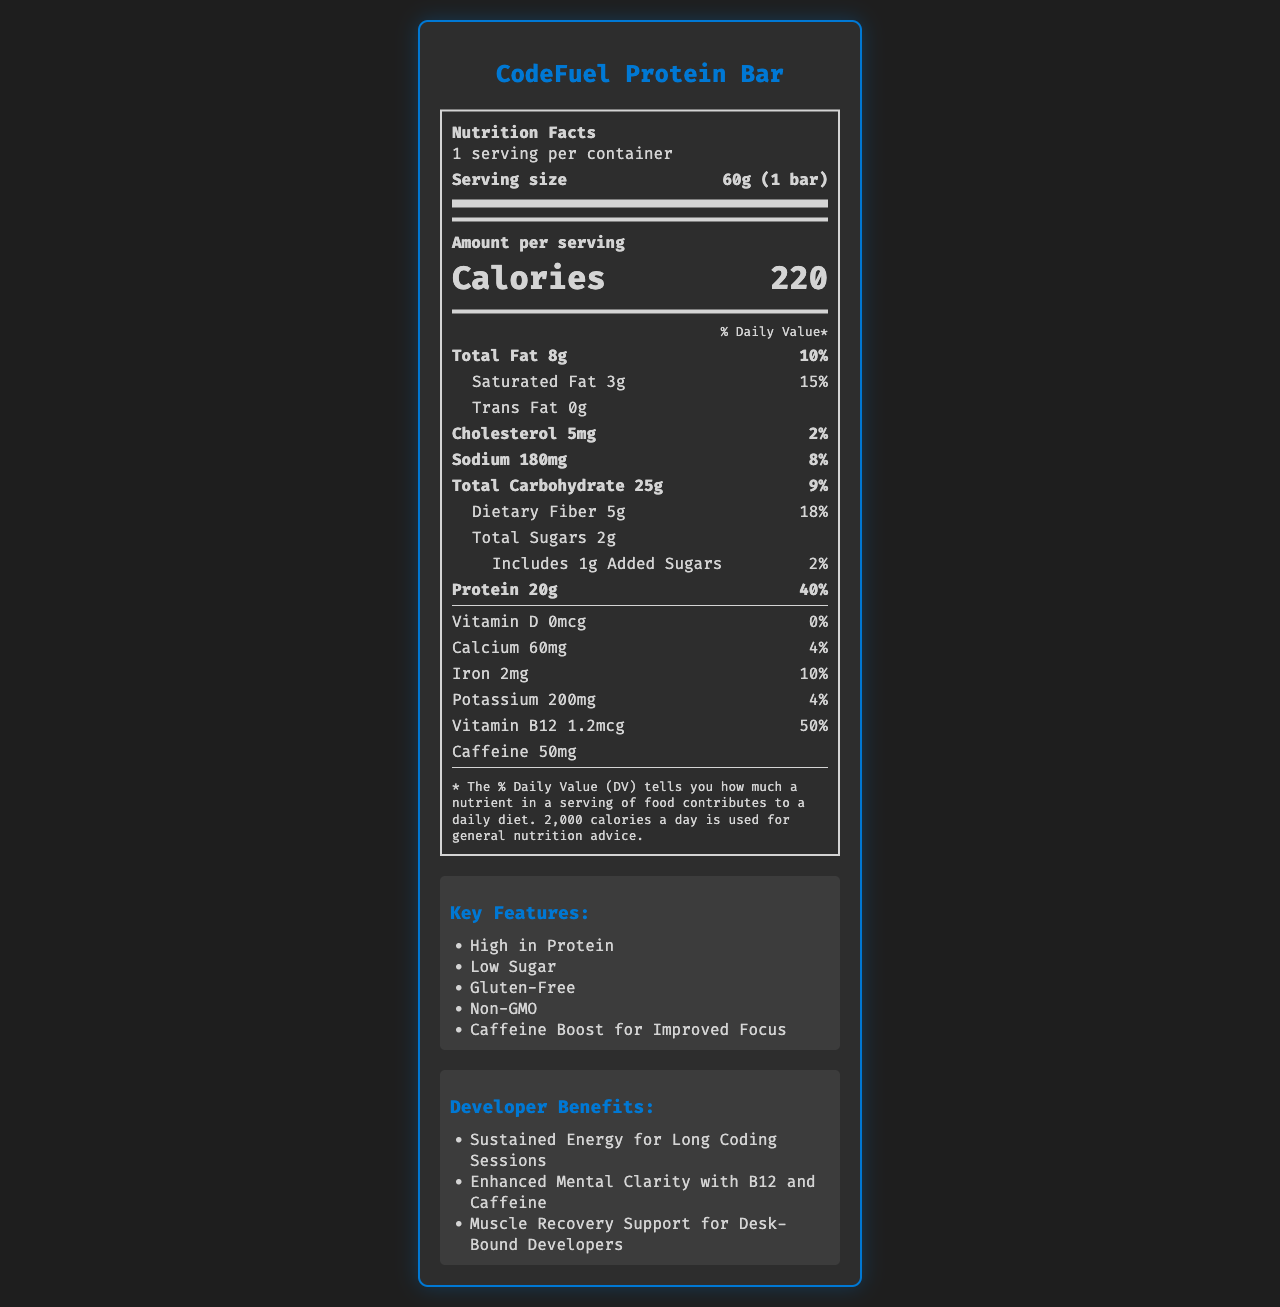what is the serving size of the CodeFuel Protein Bar? According to the document, the serving size is stated as "60g (1 bar)" under the nutrition facts section.
Answer: 60g (1 bar) how many calories are there per serving? The document shows "Calories 220" as the amount per serving.
Answer: 220 which ingredient provides a natural source of caffeine? Among the listed ingredients, Green Tea Extract is known to be a natural source of caffeine.
Answer: Green Tea Extract what is the daily value percentage of saturated fat in the CodeFuel Protein Bar? The label specifies that the daily value for saturated fat is 15%.
Answer: 15% how much protein does one serving of the CodeFuel Protein Bar contain? The nutrition facts clearly state that one serving contains 20g of protein.
Answer: 20g which of the following is an allergen in the CodeFuel Protein Bar? A. Soy B. Peanuts C. Milk The document clearly lists "Contains Milk and Tree Nuts (Almonds)" under allergens.
Answer: C. Milk which vitamin is included in the largest percentage of daily value per serving? A. Vitamin D B. Calcium C. Vitamin B12 Vitamin B12 has a 50% daily value per serving, the highest among the listed vitamins and minerals.
Answer: C. Vitamin B12 does the CodeFuel Protein Bar contain trans fat? The label states “Trans Fat 0g,” indicating there is no trans fat.
Answer: No summarize the main benefits of the CodeFuel Protein Bar for developers. The document highlights multiple benefits targeted towards developers, including high protein, low sugar, caffeine boost, and specific developer benefits such as sustained energy, mental clarity, and muscle recovery support.
Answer: The CodeFuel Protein Bar offers high protein content, low sugar, and caffeine for improved focus. It also supports sustained energy for long coding sessions, enhances mental clarity with Vitamin B12 and caffeine, and aids muscle recovery for desk-bound developers. what is the exact amount of iron in one serving? The nutrition facts indicate that each serving contains 2mg of iron.
Answer: 2mg is the CodeFuel Protein Bar gluten-free? The "Gluten-Free" claim is listed under the key features of the product.
Answer: Yes how many servings are there in each container of the CodeFuel Protein Bar? The document specifies "1 serving per container."
Answer: 1 can you determine how many bars come in a box from the provided information? The document only provides nutrition information for a single bar and does not specify the number of bars in a box or container.
Answer: Not enough information 